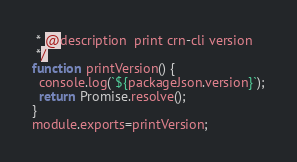Convert code to text. <code><loc_0><loc_0><loc_500><loc_500><_JavaScript_> * @description  print crn-cli version 
 */
function printVersion() {
  console.log(`${packageJson.version}`);
  return Promise.resolve();
}
module.exports=printVersion;</code> 